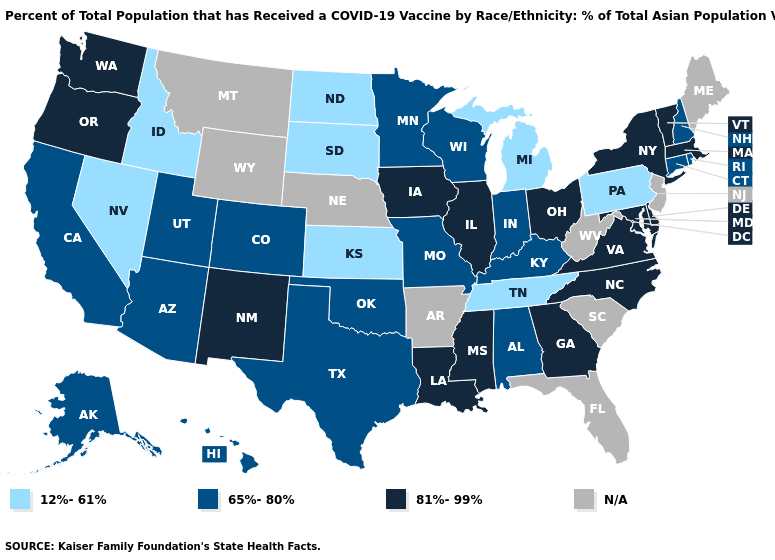What is the highest value in states that border Maryland?
Be succinct. 81%-99%. Name the states that have a value in the range N/A?
Give a very brief answer. Arkansas, Florida, Maine, Montana, Nebraska, New Jersey, South Carolina, West Virginia, Wyoming. What is the value of Illinois?
Keep it brief. 81%-99%. What is the value of Louisiana?
Write a very short answer. 81%-99%. Does Minnesota have the lowest value in the MidWest?
Be succinct. No. Does Connecticut have the lowest value in the Northeast?
Be succinct. No. Among the states that border Colorado , does New Mexico have the highest value?
Keep it brief. Yes. Name the states that have a value in the range N/A?
Be succinct. Arkansas, Florida, Maine, Montana, Nebraska, New Jersey, South Carolina, West Virginia, Wyoming. Name the states that have a value in the range 65%-80%?
Be succinct. Alabama, Alaska, Arizona, California, Colorado, Connecticut, Hawaii, Indiana, Kentucky, Minnesota, Missouri, New Hampshire, Oklahoma, Rhode Island, Texas, Utah, Wisconsin. Which states have the lowest value in the Northeast?
Concise answer only. Pennsylvania. Does Tennessee have the lowest value in the USA?
Be succinct. Yes. Name the states that have a value in the range 65%-80%?
Keep it brief. Alabama, Alaska, Arizona, California, Colorado, Connecticut, Hawaii, Indiana, Kentucky, Minnesota, Missouri, New Hampshire, Oklahoma, Rhode Island, Texas, Utah, Wisconsin. What is the value of Maryland?
Give a very brief answer. 81%-99%. 